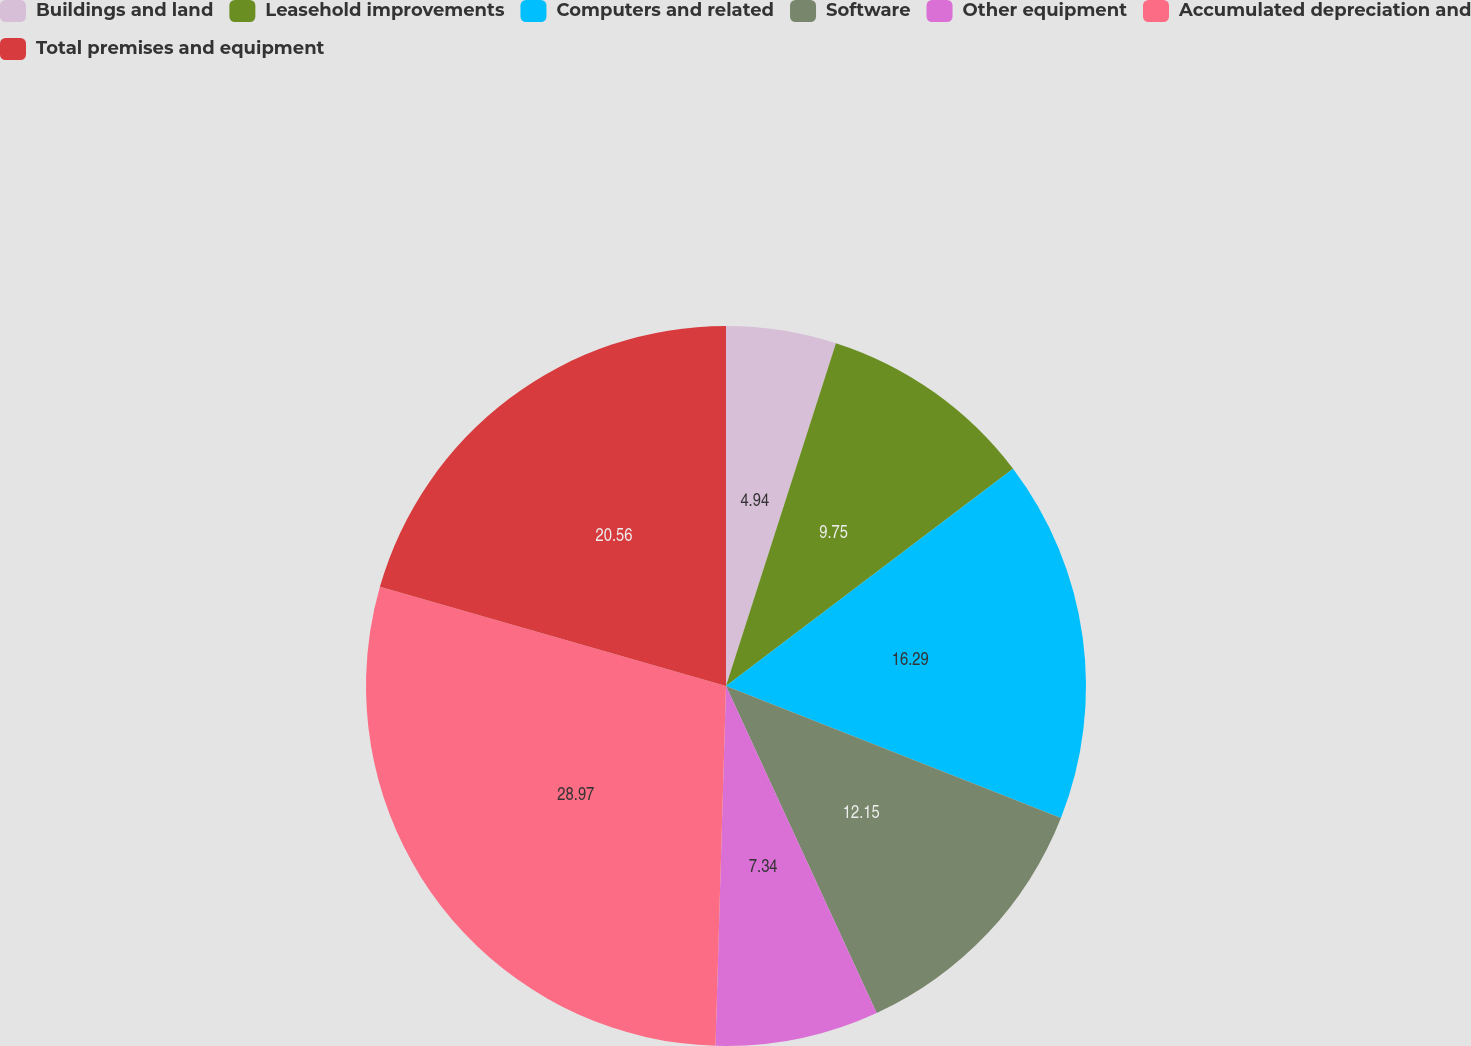Convert chart. <chart><loc_0><loc_0><loc_500><loc_500><pie_chart><fcel>Buildings and land<fcel>Leasehold improvements<fcel>Computers and related<fcel>Software<fcel>Other equipment<fcel>Accumulated depreciation and<fcel>Total premises and equipment<nl><fcel>4.94%<fcel>9.75%<fcel>16.29%<fcel>12.15%<fcel>7.34%<fcel>28.98%<fcel>20.56%<nl></chart> 